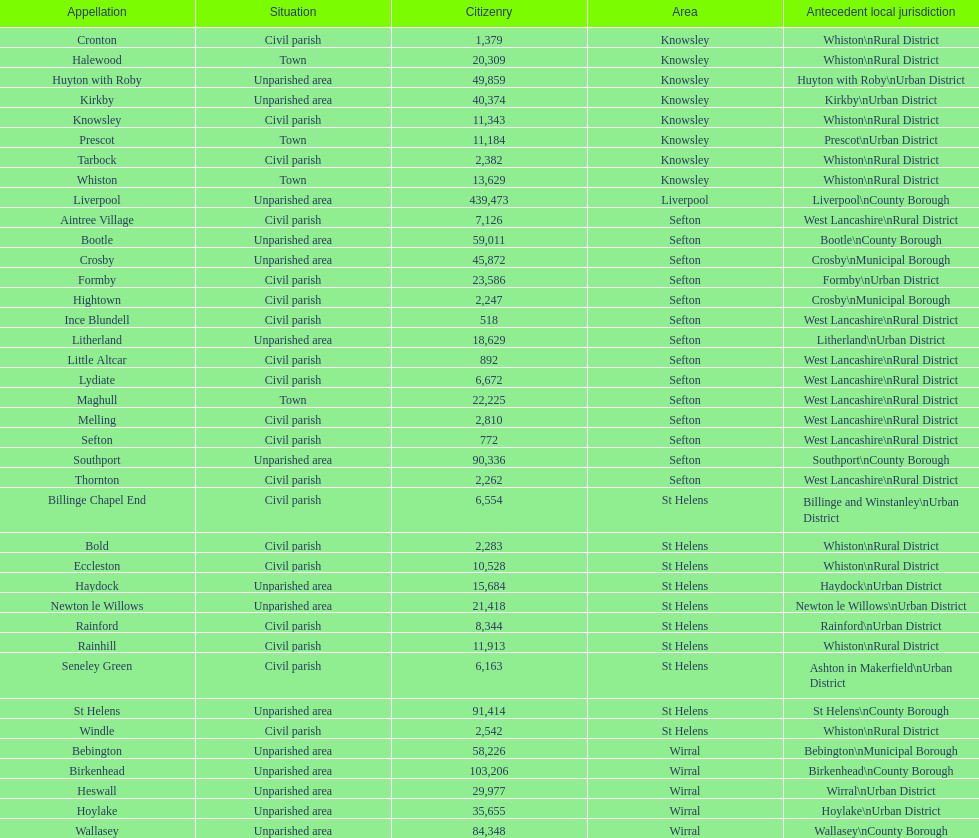How many regions are unparished zones? 15. 